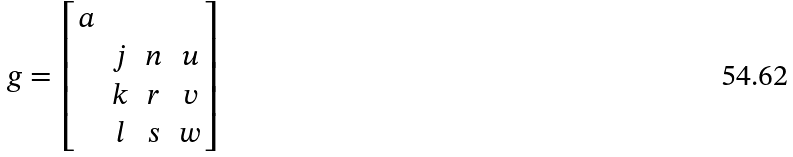Convert formula to latex. <formula><loc_0><loc_0><loc_500><loc_500>g = \begin{bmatrix} a & & & \\ & j & n & u \\ & k & r & v \\ & l & s & w \end{bmatrix}</formula> 